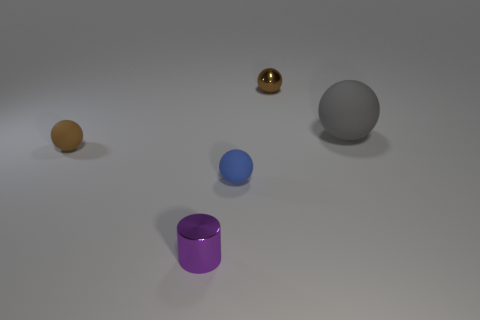There is a rubber object that is the same color as the tiny shiny ball; what is its shape?
Your response must be concise. Sphere. Are there any green rubber cylinders that have the same size as the gray ball?
Your answer should be compact. No. What is the color of the small metallic thing that is the same shape as the big gray rubber thing?
Offer a terse response. Brown. There is a metal object left of the metallic ball; is it the same size as the brown ball that is behind the big ball?
Offer a terse response. Yes. Are there any other small purple shiny things that have the same shape as the small purple shiny thing?
Your answer should be very brief. No. Are there an equal number of small brown rubber things that are in front of the big thing and big red spheres?
Provide a succinct answer. No. Do the brown metallic thing and the brown ball that is in front of the large sphere have the same size?
Your answer should be compact. Yes. How many other small things have the same material as the small blue object?
Your answer should be compact. 1. Is the size of the blue rubber sphere the same as the brown matte object?
Offer a very short reply. Yes. Is there any other thing that is the same color as the metal cylinder?
Your answer should be very brief. No. 